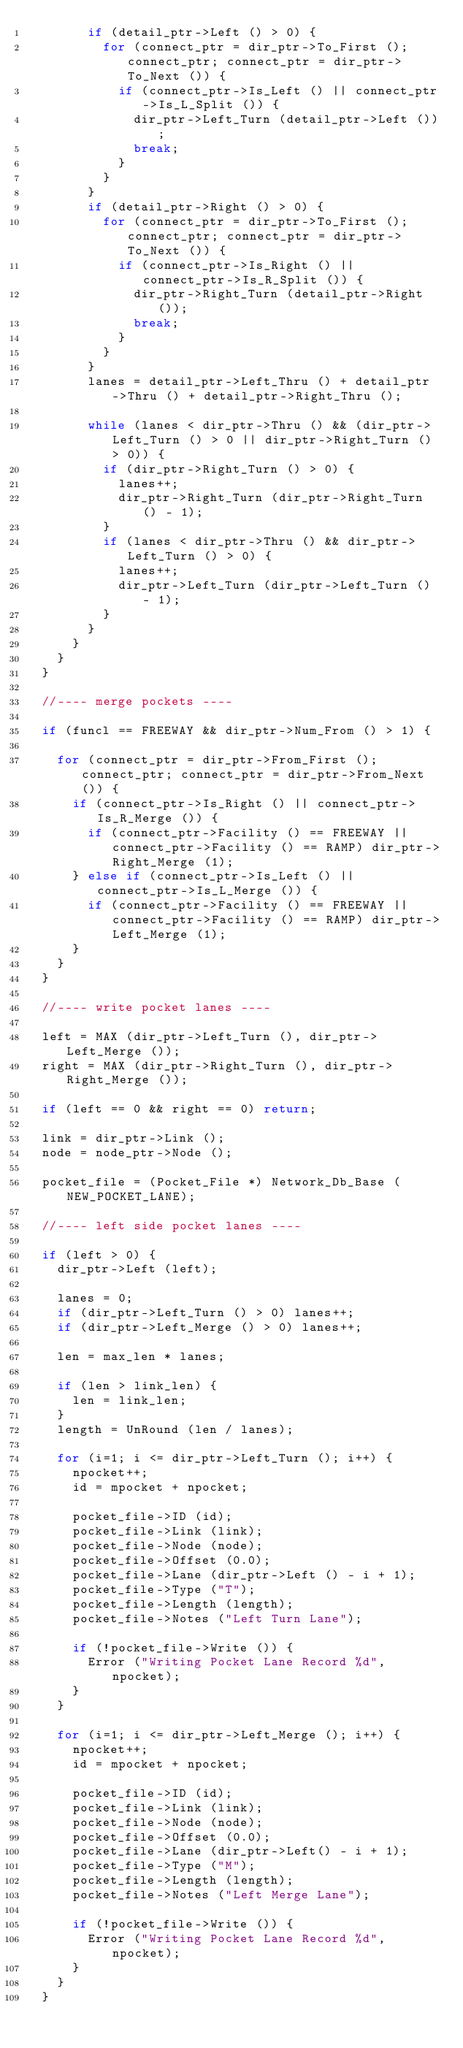Convert code to text. <code><loc_0><loc_0><loc_500><loc_500><_C++_>				if (detail_ptr->Left () > 0) {
					for (connect_ptr = dir_ptr->To_First (); connect_ptr; connect_ptr = dir_ptr->To_Next ()) {
						if (connect_ptr->Is_Left () || connect_ptr->Is_L_Split ()) {
							dir_ptr->Left_Turn (detail_ptr->Left ());
							break;
						}
					}
				}
				if (detail_ptr->Right () > 0) {
					for (connect_ptr = dir_ptr->To_First (); connect_ptr; connect_ptr = dir_ptr->To_Next ()) {
						if (connect_ptr->Is_Right () || connect_ptr->Is_R_Split ()) {
							dir_ptr->Right_Turn (detail_ptr->Right ());
							break;
						}
					}
				}
				lanes = detail_ptr->Left_Thru () + detail_ptr->Thru () + detail_ptr->Right_Thru ();

				while (lanes < dir_ptr->Thru () && (dir_ptr->Left_Turn () > 0 || dir_ptr->Right_Turn () > 0)) {
					if (dir_ptr->Right_Turn () > 0) {
						lanes++;
						dir_ptr->Right_Turn (dir_ptr->Right_Turn () - 1);
					}
					if (lanes < dir_ptr->Thru () && dir_ptr->Left_Turn () > 0) {
						lanes++;
						dir_ptr->Left_Turn (dir_ptr->Left_Turn () - 1);
					}
				}
			}
		}
	}

	//---- merge pockets ----

	if (funcl == FREEWAY && dir_ptr->Num_From () > 1) {

		for (connect_ptr = dir_ptr->From_First (); connect_ptr; connect_ptr = dir_ptr->From_Next ()) {
			if (connect_ptr->Is_Right () || connect_ptr->Is_R_Merge ()) {
				if (connect_ptr->Facility () == FREEWAY || connect_ptr->Facility () == RAMP) dir_ptr->Right_Merge (1);
			} else if (connect_ptr->Is_Left () || connect_ptr->Is_L_Merge ()) {
				if (connect_ptr->Facility () == FREEWAY || connect_ptr->Facility () == RAMP) dir_ptr->Left_Merge (1);
			}
		}
	}

	//---- write pocket lanes ----

	left = MAX (dir_ptr->Left_Turn (), dir_ptr->Left_Merge ());
	right = MAX (dir_ptr->Right_Turn (), dir_ptr->Right_Merge ());

	if (left == 0 && right == 0) return;

	link = dir_ptr->Link ();
	node = node_ptr->Node ();

	pocket_file = (Pocket_File *) Network_Db_Base (NEW_POCKET_LANE);

	//---- left side pocket lanes ----

	if (left > 0) {
		dir_ptr->Left (left);

		lanes = 0;
		if (dir_ptr->Left_Turn () > 0) lanes++;
		if (dir_ptr->Left_Merge () > 0) lanes++;

		len = max_len * lanes;

		if (len > link_len) {
			len = link_len;
		}
		length = UnRound (len / lanes);

		for (i=1; i <= dir_ptr->Left_Turn (); i++) {
			npocket++;
			id = mpocket + npocket;

			pocket_file->ID (id);
			pocket_file->Link (link);
			pocket_file->Node (node);
			pocket_file->Offset (0.0);
			pocket_file->Lane (dir_ptr->Left () - i + 1);
			pocket_file->Type ("T");
			pocket_file->Length (length);
			pocket_file->Notes ("Left Turn Lane");

			if (!pocket_file->Write ()) {
				Error ("Writing Pocket Lane Record %d", npocket);
			}
		}

		for (i=1; i <= dir_ptr->Left_Merge (); i++) {
			npocket++;
			id = mpocket + npocket;

			pocket_file->ID (id);
			pocket_file->Link (link);
			pocket_file->Node (node);
			pocket_file->Offset (0.0);
			pocket_file->Lane (dir_ptr->Left() - i + 1);
			pocket_file->Type ("M");
			pocket_file->Length (length);
			pocket_file->Notes ("Left Merge Lane");

			if (!pocket_file->Write ()) {
				Error ("Writing Pocket Lane Record %d", npocket);
			}
		}
	}
</code> 